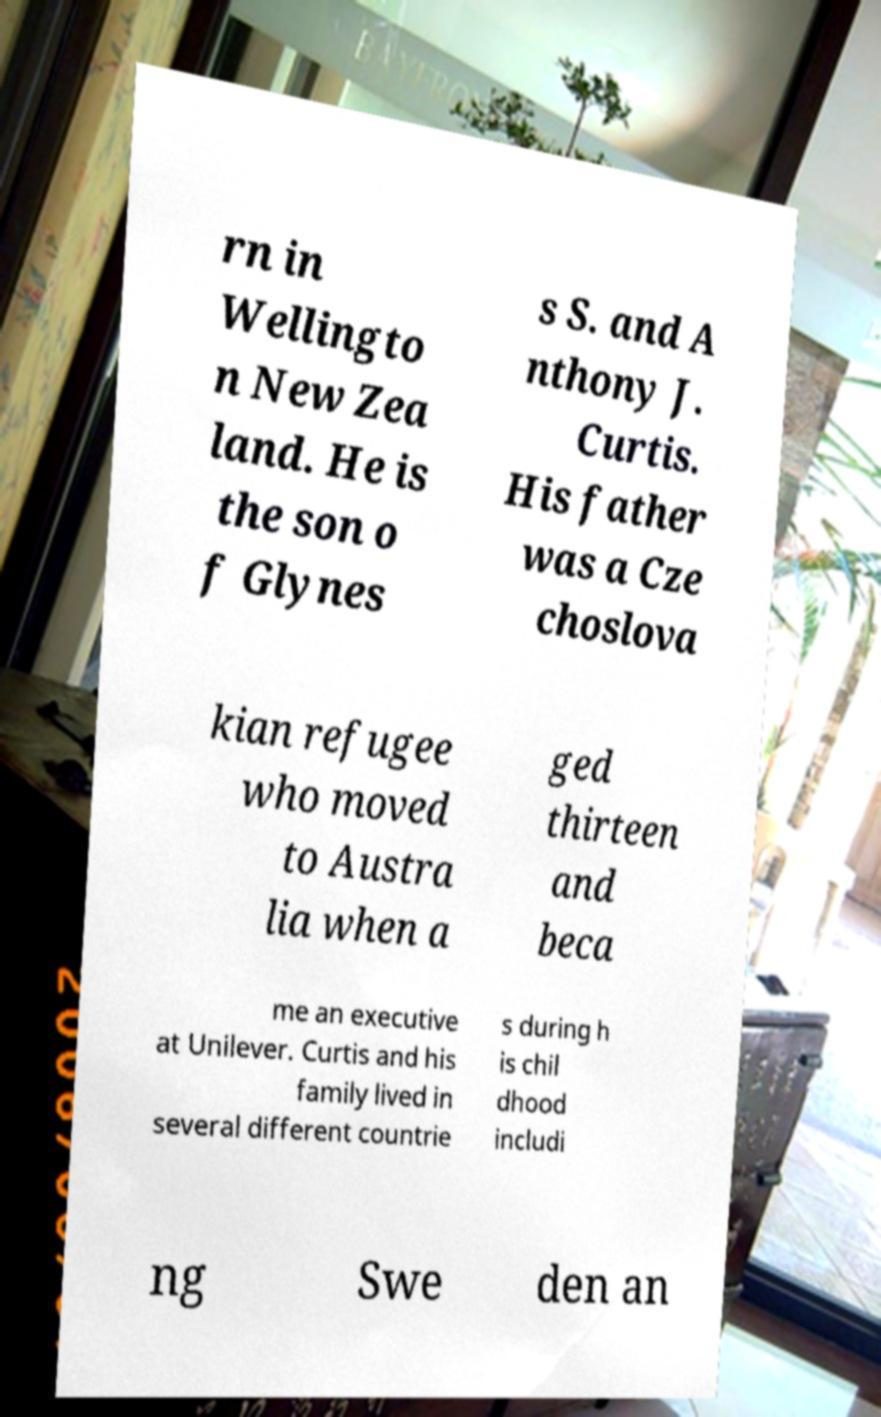Could you extract and type out the text from this image? rn in Wellingto n New Zea land. He is the son o f Glynes s S. and A nthony J. Curtis. His father was a Cze choslova kian refugee who moved to Austra lia when a ged thirteen and beca me an executive at Unilever. Curtis and his family lived in several different countrie s during h is chil dhood includi ng Swe den an 